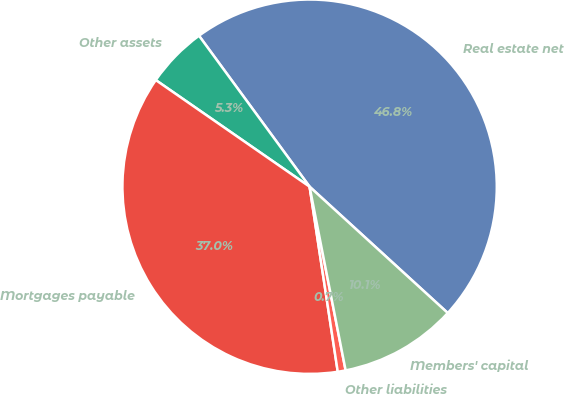Convert chart to OTSL. <chart><loc_0><loc_0><loc_500><loc_500><pie_chart><fcel>Real estate net<fcel>Other assets<fcel>Mortgages payable<fcel>Other liabilities<fcel>Members' capital<nl><fcel>46.85%<fcel>5.29%<fcel>37.05%<fcel>0.68%<fcel>10.13%<nl></chart> 